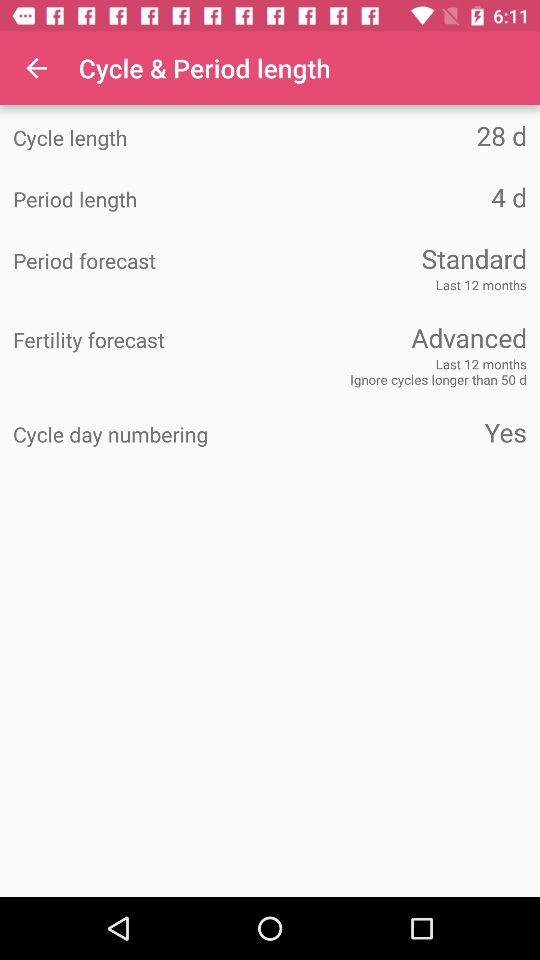How many days longer is the cycle length than the period length?
Answer the question using a single word or phrase. 24 